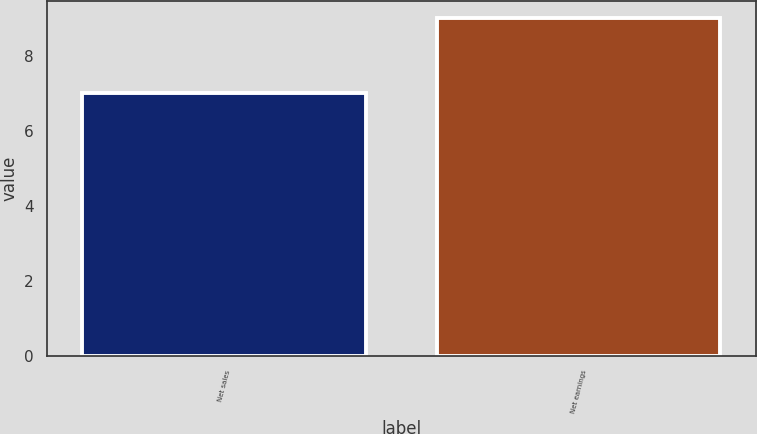<chart> <loc_0><loc_0><loc_500><loc_500><bar_chart><fcel>Net sales<fcel>Net earnings<nl><fcel>7<fcel>9<nl></chart> 